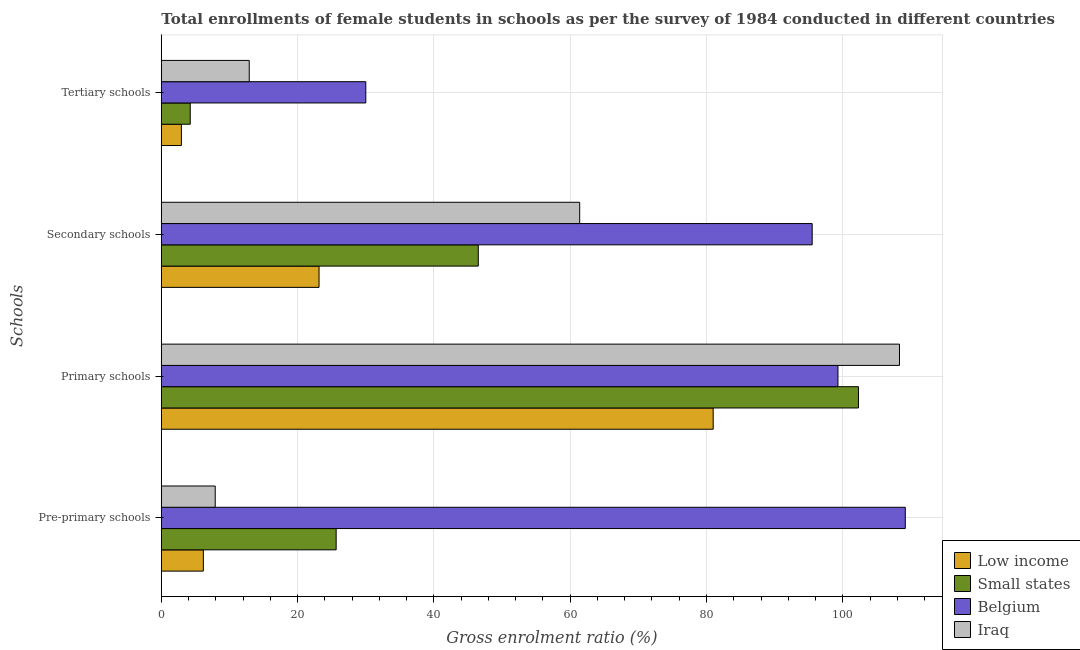How many different coloured bars are there?
Your answer should be compact. 4. Are the number of bars per tick equal to the number of legend labels?
Keep it short and to the point. Yes. Are the number of bars on each tick of the Y-axis equal?
Keep it short and to the point. Yes. How many bars are there on the 2nd tick from the top?
Provide a succinct answer. 4. How many bars are there on the 4th tick from the bottom?
Provide a short and direct response. 4. What is the label of the 3rd group of bars from the top?
Offer a terse response. Primary schools. What is the gross enrolment ratio(female) in secondary schools in Small states?
Offer a terse response. 46.51. Across all countries, what is the maximum gross enrolment ratio(female) in primary schools?
Make the answer very short. 108.32. Across all countries, what is the minimum gross enrolment ratio(female) in primary schools?
Make the answer very short. 80.98. In which country was the gross enrolment ratio(female) in tertiary schools maximum?
Your answer should be compact. Belgium. In which country was the gross enrolment ratio(female) in secondary schools minimum?
Provide a succinct answer. Low income. What is the total gross enrolment ratio(female) in pre-primary schools in the graph?
Your response must be concise. 148.91. What is the difference between the gross enrolment ratio(female) in pre-primary schools in Small states and that in Iraq?
Make the answer very short. 17.75. What is the difference between the gross enrolment ratio(female) in tertiary schools in Small states and the gross enrolment ratio(female) in pre-primary schools in Iraq?
Keep it short and to the point. -3.67. What is the average gross enrolment ratio(female) in tertiary schools per country?
Provide a short and direct response. 12.53. What is the difference between the gross enrolment ratio(female) in primary schools and gross enrolment ratio(female) in tertiary schools in Iraq?
Your response must be concise. 95.42. In how many countries, is the gross enrolment ratio(female) in primary schools greater than 4 %?
Your answer should be very brief. 4. What is the ratio of the gross enrolment ratio(female) in secondary schools in Small states to that in Low income?
Offer a terse response. 2.01. What is the difference between the highest and the second highest gross enrolment ratio(female) in secondary schools?
Offer a very short reply. 34.12. What is the difference between the highest and the lowest gross enrolment ratio(female) in pre-primary schools?
Keep it short and to the point. 103.01. In how many countries, is the gross enrolment ratio(female) in tertiary schools greater than the average gross enrolment ratio(female) in tertiary schools taken over all countries?
Keep it short and to the point. 2. What does the 4th bar from the top in Pre-primary schools represents?
Give a very brief answer. Low income. What does the 2nd bar from the bottom in Pre-primary schools represents?
Your answer should be compact. Small states. Is it the case that in every country, the sum of the gross enrolment ratio(female) in pre-primary schools and gross enrolment ratio(female) in primary schools is greater than the gross enrolment ratio(female) in secondary schools?
Your response must be concise. Yes. How many bars are there?
Provide a short and direct response. 16. Are all the bars in the graph horizontal?
Ensure brevity in your answer.  Yes. How many countries are there in the graph?
Ensure brevity in your answer.  4. What is the difference between two consecutive major ticks on the X-axis?
Provide a short and direct response. 20. Are the values on the major ticks of X-axis written in scientific E-notation?
Provide a succinct answer. No. Does the graph contain any zero values?
Provide a succinct answer. No. Where does the legend appear in the graph?
Offer a very short reply. Bottom right. What is the title of the graph?
Your answer should be compact. Total enrollments of female students in schools as per the survey of 1984 conducted in different countries. What is the label or title of the X-axis?
Ensure brevity in your answer.  Gross enrolment ratio (%). What is the label or title of the Y-axis?
Your answer should be compact. Schools. What is the Gross enrolment ratio (%) in Low income in Pre-primary schools?
Provide a succinct answer. 6.17. What is the Gross enrolment ratio (%) of Small states in Pre-primary schools?
Provide a succinct answer. 25.66. What is the Gross enrolment ratio (%) in Belgium in Pre-primary schools?
Give a very brief answer. 109.17. What is the Gross enrolment ratio (%) of Iraq in Pre-primary schools?
Keep it short and to the point. 7.91. What is the Gross enrolment ratio (%) of Low income in Primary schools?
Offer a terse response. 80.98. What is the Gross enrolment ratio (%) of Small states in Primary schools?
Ensure brevity in your answer.  102.3. What is the Gross enrolment ratio (%) in Belgium in Primary schools?
Keep it short and to the point. 99.29. What is the Gross enrolment ratio (%) in Iraq in Primary schools?
Offer a terse response. 108.32. What is the Gross enrolment ratio (%) in Low income in Secondary schools?
Your answer should be very brief. 23.15. What is the Gross enrolment ratio (%) in Small states in Secondary schools?
Keep it short and to the point. 46.51. What is the Gross enrolment ratio (%) of Belgium in Secondary schools?
Make the answer very short. 95.51. What is the Gross enrolment ratio (%) of Iraq in Secondary schools?
Offer a terse response. 61.39. What is the Gross enrolment ratio (%) of Low income in Tertiary schools?
Your answer should be very brief. 2.95. What is the Gross enrolment ratio (%) of Small states in Tertiary schools?
Offer a terse response. 4.24. What is the Gross enrolment ratio (%) of Belgium in Tertiary schools?
Ensure brevity in your answer.  30.01. What is the Gross enrolment ratio (%) in Iraq in Tertiary schools?
Offer a terse response. 12.9. Across all Schools, what is the maximum Gross enrolment ratio (%) in Low income?
Offer a terse response. 80.98. Across all Schools, what is the maximum Gross enrolment ratio (%) in Small states?
Offer a very short reply. 102.3. Across all Schools, what is the maximum Gross enrolment ratio (%) of Belgium?
Provide a succinct answer. 109.17. Across all Schools, what is the maximum Gross enrolment ratio (%) in Iraq?
Your answer should be very brief. 108.32. Across all Schools, what is the minimum Gross enrolment ratio (%) in Low income?
Your answer should be compact. 2.95. Across all Schools, what is the minimum Gross enrolment ratio (%) in Small states?
Your response must be concise. 4.24. Across all Schools, what is the minimum Gross enrolment ratio (%) of Belgium?
Provide a short and direct response. 30.01. Across all Schools, what is the minimum Gross enrolment ratio (%) of Iraq?
Provide a short and direct response. 7.91. What is the total Gross enrolment ratio (%) of Low income in the graph?
Your response must be concise. 113.24. What is the total Gross enrolment ratio (%) of Small states in the graph?
Make the answer very short. 178.71. What is the total Gross enrolment ratio (%) of Belgium in the graph?
Your response must be concise. 333.99. What is the total Gross enrolment ratio (%) in Iraq in the graph?
Offer a very short reply. 190.53. What is the difference between the Gross enrolment ratio (%) of Low income in Pre-primary schools and that in Primary schools?
Keep it short and to the point. -74.82. What is the difference between the Gross enrolment ratio (%) of Small states in Pre-primary schools and that in Primary schools?
Offer a very short reply. -76.64. What is the difference between the Gross enrolment ratio (%) of Belgium in Pre-primary schools and that in Primary schools?
Your response must be concise. 9.88. What is the difference between the Gross enrolment ratio (%) of Iraq in Pre-primary schools and that in Primary schools?
Make the answer very short. -100.41. What is the difference between the Gross enrolment ratio (%) of Low income in Pre-primary schools and that in Secondary schools?
Provide a short and direct response. -16.98. What is the difference between the Gross enrolment ratio (%) of Small states in Pre-primary schools and that in Secondary schools?
Make the answer very short. -20.86. What is the difference between the Gross enrolment ratio (%) of Belgium in Pre-primary schools and that in Secondary schools?
Your answer should be compact. 13.66. What is the difference between the Gross enrolment ratio (%) of Iraq in Pre-primary schools and that in Secondary schools?
Your response must be concise. -53.48. What is the difference between the Gross enrolment ratio (%) of Low income in Pre-primary schools and that in Tertiary schools?
Your answer should be very brief. 3.22. What is the difference between the Gross enrolment ratio (%) in Small states in Pre-primary schools and that in Tertiary schools?
Your answer should be very brief. 21.41. What is the difference between the Gross enrolment ratio (%) of Belgium in Pre-primary schools and that in Tertiary schools?
Provide a short and direct response. 79.17. What is the difference between the Gross enrolment ratio (%) in Iraq in Pre-primary schools and that in Tertiary schools?
Offer a terse response. -5. What is the difference between the Gross enrolment ratio (%) of Low income in Primary schools and that in Secondary schools?
Your answer should be very brief. 57.84. What is the difference between the Gross enrolment ratio (%) of Small states in Primary schools and that in Secondary schools?
Offer a very short reply. 55.79. What is the difference between the Gross enrolment ratio (%) in Belgium in Primary schools and that in Secondary schools?
Make the answer very short. 3.78. What is the difference between the Gross enrolment ratio (%) of Iraq in Primary schools and that in Secondary schools?
Your answer should be very brief. 46.93. What is the difference between the Gross enrolment ratio (%) of Low income in Primary schools and that in Tertiary schools?
Your response must be concise. 78.04. What is the difference between the Gross enrolment ratio (%) of Small states in Primary schools and that in Tertiary schools?
Provide a succinct answer. 98.06. What is the difference between the Gross enrolment ratio (%) of Belgium in Primary schools and that in Tertiary schools?
Make the answer very short. 69.29. What is the difference between the Gross enrolment ratio (%) of Iraq in Primary schools and that in Tertiary schools?
Provide a succinct answer. 95.42. What is the difference between the Gross enrolment ratio (%) of Low income in Secondary schools and that in Tertiary schools?
Ensure brevity in your answer.  20.2. What is the difference between the Gross enrolment ratio (%) in Small states in Secondary schools and that in Tertiary schools?
Your answer should be very brief. 42.27. What is the difference between the Gross enrolment ratio (%) of Belgium in Secondary schools and that in Tertiary schools?
Make the answer very short. 65.51. What is the difference between the Gross enrolment ratio (%) in Iraq in Secondary schools and that in Tertiary schools?
Your response must be concise. 48.49. What is the difference between the Gross enrolment ratio (%) of Low income in Pre-primary schools and the Gross enrolment ratio (%) of Small states in Primary schools?
Ensure brevity in your answer.  -96.13. What is the difference between the Gross enrolment ratio (%) in Low income in Pre-primary schools and the Gross enrolment ratio (%) in Belgium in Primary schools?
Keep it short and to the point. -93.12. What is the difference between the Gross enrolment ratio (%) in Low income in Pre-primary schools and the Gross enrolment ratio (%) in Iraq in Primary schools?
Your answer should be compact. -102.16. What is the difference between the Gross enrolment ratio (%) in Small states in Pre-primary schools and the Gross enrolment ratio (%) in Belgium in Primary schools?
Ensure brevity in your answer.  -73.64. What is the difference between the Gross enrolment ratio (%) in Small states in Pre-primary schools and the Gross enrolment ratio (%) in Iraq in Primary schools?
Provide a succinct answer. -82.67. What is the difference between the Gross enrolment ratio (%) of Belgium in Pre-primary schools and the Gross enrolment ratio (%) of Iraq in Primary schools?
Ensure brevity in your answer.  0.85. What is the difference between the Gross enrolment ratio (%) in Low income in Pre-primary schools and the Gross enrolment ratio (%) in Small states in Secondary schools?
Your answer should be very brief. -40.34. What is the difference between the Gross enrolment ratio (%) in Low income in Pre-primary schools and the Gross enrolment ratio (%) in Belgium in Secondary schools?
Offer a very short reply. -89.34. What is the difference between the Gross enrolment ratio (%) in Low income in Pre-primary schools and the Gross enrolment ratio (%) in Iraq in Secondary schools?
Your response must be concise. -55.23. What is the difference between the Gross enrolment ratio (%) in Small states in Pre-primary schools and the Gross enrolment ratio (%) in Belgium in Secondary schools?
Your answer should be compact. -69.86. What is the difference between the Gross enrolment ratio (%) in Small states in Pre-primary schools and the Gross enrolment ratio (%) in Iraq in Secondary schools?
Your answer should be very brief. -35.74. What is the difference between the Gross enrolment ratio (%) in Belgium in Pre-primary schools and the Gross enrolment ratio (%) in Iraq in Secondary schools?
Your response must be concise. 47.78. What is the difference between the Gross enrolment ratio (%) of Low income in Pre-primary schools and the Gross enrolment ratio (%) of Small states in Tertiary schools?
Give a very brief answer. 1.92. What is the difference between the Gross enrolment ratio (%) in Low income in Pre-primary schools and the Gross enrolment ratio (%) in Belgium in Tertiary schools?
Provide a succinct answer. -23.84. What is the difference between the Gross enrolment ratio (%) of Low income in Pre-primary schools and the Gross enrolment ratio (%) of Iraq in Tertiary schools?
Offer a very short reply. -6.74. What is the difference between the Gross enrolment ratio (%) of Small states in Pre-primary schools and the Gross enrolment ratio (%) of Belgium in Tertiary schools?
Your answer should be very brief. -4.35. What is the difference between the Gross enrolment ratio (%) in Small states in Pre-primary schools and the Gross enrolment ratio (%) in Iraq in Tertiary schools?
Provide a short and direct response. 12.75. What is the difference between the Gross enrolment ratio (%) of Belgium in Pre-primary schools and the Gross enrolment ratio (%) of Iraq in Tertiary schools?
Your answer should be compact. 96.27. What is the difference between the Gross enrolment ratio (%) of Low income in Primary schools and the Gross enrolment ratio (%) of Small states in Secondary schools?
Your answer should be very brief. 34.47. What is the difference between the Gross enrolment ratio (%) in Low income in Primary schools and the Gross enrolment ratio (%) in Belgium in Secondary schools?
Offer a terse response. -14.53. What is the difference between the Gross enrolment ratio (%) of Low income in Primary schools and the Gross enrolment ratio (%) of Iraq in Secondary schools?
Offer a very short reply. 19.59. What is the difference between the Gross enrolment ratio (%) in Small states in Primary schools and the Gross enrolment ratio (%) in Belgium in Secondary schools?
Give a very brief answer. 6.79. What is the difference between the Gross enrolment ratio (%) of Small states in Primary schools and the Gross enrolment ratio (%) of Iraq in Secondary schools?
Offer a very short reply. 40.91. What is the difference between the Gross enrolment ratio (%) of Belgium in Primary schools and the Gross enrolment ratio (%) of Iraq in Secondary schools?
Keep it short and to the point. 37.9. What is the difference between the Gross enrolment ratio (%) of Low income in Primary schools and the Gross enrolment ratio (%) of Small states in Tertiary schools?
Your answer should be very brief. 76.74. What is the difference between the Gross enrolment ratio (%) of Low income in Primary schools and the Gross enrolment ratio (%) of Belgium in Tertiary schools?
Your response must be concise. 50.98. What is the difference between the Gross enrolment ratio (%) of Low income in Primary schools and the Gross enrolment ratio (%) of Iraq in Tertiary schools?
Your response must be concise. 68.08. What is the difference between the Gross enrolment ratio (%) in Small states in Primary schools and the Gross enrolment ratio (%) in Belgium in Tertiary schools?
Your answer should be very brief. 72.29. What is the difference between the Gross enrolment ratio (%) in Small states in Primary schools and the Gross enrolment ratio (%) in Iraq in Tertiary schools?
Offer a terse response. 89.4. What is the difference between the Gross enrolment ratio (%) of Belgium in Primary schools and the Gross enrolment ratio (%) of Iraq in Tertiary schools?
Offer a terse response. 86.39. What is the difference between the Gross enrolment ratio (%) of Low income in Secondary schools and the Gross enrolment ratio (%) of Small states in Tertiary schools?
Provide a short and direct response. 18.9. What is the difference between the Gross enrolment ratio (%) in Low income in Secondary schools and the Gross enrolment ratio (%) in Belgium in Tertiary schools?
Keep it short and to the point. -6.86. What is the difference between the Gross enrolment ratio (%) of Low income in Secondary schools and the Gross enrolment ratio (%) of Iraq in Tertiary schools?
Make the answer very short. 10.24. What is the difference between the Gross enrolment ratio (%) in Small states in Secondary schools and the Gross enrolment ratio (%) in Belgium in Tertiary schools?
Your response must be concise. 16.51. What is the difference between the Gross enrolment ratio (%) of Small states in Secondary schools and the Gross enrolment ratio (%) of Iraq in Tertiary schools?
Provide a short and direct response. 33.61. What is the difference between the Gross enrolment ratio (%) in Belgium in Secondary schools and the Gross enrolment ratio (%) in Iraq in Tertiary schools?
Provide a succinct answer. 82.61. What is the average Gross enrolment ratio (%) of Low income per Schools?
Offer a terse response. 28.31. What is the average Gross enrolment ratio (%) of Small states per Schools?
Provide a short and direct response. 44.68. What is the average Gross enrolment ratio (%) in Belgium per Schools?
Give a very brief answer. 83.5. What is the average Gross enrolment ratio (%) in Iraq per Schools?
Offer a terse response. 47.63. What is the difference between the Gross enrolment ratio (%) in Low income and Gross enrolment ratio (%) in Small states in Pre-primary schools?
Your answer should be compact. -19.49. What is the difference between the Gross enrolment ratio (%) of Low income and Gross enrolment ratio (%) of Belgium in Pre-primary schools?
Provide a succinct answer. -103.01. What is the difference between the Gross enrolment ratio (%) in Low income and Gross enrolment ratio (%) in Iraq in Pre-primary schools?
Provide a succinct answer. -1.74. What is the difference between the Gross enrolment ratio (%) in Small states and Gross enrolment ratio (%) in Belgium in Pre-primary schools?
Provide a succinct answer. -83.52. What is the difference between the Gross enrolment ratio (%) of Small states and Gross enrolment ratio (%) of Iraq in Pre-primary schools?
Ensure brevity in your answer.  17.75. What is the difference between the Gross enrolment ratio (%) in Belgium and Gross enrolment ratio (%) in Iraq in Pre-primary schools?
Make the answer very short. 101.27. What is the difference between the Gross enrolment ratio (%) in Low income and Gross enrolment ratio (%) in Small states in Primary schools?
Provide a short and direct response. -21.32. What is the difference between the Gross enrolment ratio (%) of Low income and Gross enrolment ratio (%) of Belgium in Primary schools?
Your response must be concise. -18.31. What is the difference between the Gross enrolment ratio (%) in Low income and Gross enrolment ratio (%) in Iraq in Primary schools?
Your answer should be compact. -27.34. What is the difference between the Gross enrolment ratio (%) of Small states and Gross enrolment ratio (%) of Belgium in Primary schools?
Give a very brief answer. 3.01. What is the difference between the Gross enrolment ratio (%) of Small states and Gross enrolment ratio (%) of Iraq in Primary schools?
Offer a terse response. -6.02. What is the difference between the Gross enrolment ratio (%) in Belgium and Gross enrolment ratio (%) in Iraq in Primary schools?
Ensure brevity in your answer.  -9.03. What is the difference between the Gross enrolment ratio (%) of Low income and Gross enrolment ratio (%) of Small states in Secondary schools?
Your answer should be very brief. -23.37. What is the difference between the Gross enrolment ratio (%) in Low income and Gross enrolment ratio (%) in Belgium in Secondary schools?
Provide a short and direct response. -72.37. What is the difference between the Gross enrolment ratio (%) in Low income and Gross enrolment ratio (%) in Iraq in Secondary schools?
Ensure brevity in your answer.  -38.25. What is the difference between the Gross enrolment ratio (%) in Small states and Gross enrolment ratio (%) in Belgium in Secondary schools?
Make the answer very short. -49. What is the difference between the Gross enrolment ratio (%) in Small states and Gross enrolment ratio (%) in Iraq in Secondary schools?
Keep it short and to the point. -14.88. What is the difference between the Gross enrolment ratio (%) in Belgium and Gross enrolment ratio (%) in Iraq in Secondary schools?
Your response must be concise. 34.12. What is the difference between the Gross enrolment ratio (%) in Low income and Gross enrolment ratio (%) in Small states in Tertiary schools?
Give a very brief answer. -1.3. What is the difference between the Gross enrolment ratio (%) of Low income and Gross enrolment ratio (%) of Belgium in Tertiary schools?
Ensure brevity in your answer.  -27.06. What is the difference between the Gross enrolment ratio (%) in Low income and Gross enrolment ratio (%) in Iraq in Tertiary schools?
Keep it short and to the point. -9.96. What is the difference between the Gross enrolment ratio (%) of Small states and Gross enrolment ratio (%) of Belgium in Tertiary schools?
Your response must be concise. -25.76. What is the difference between the Gross enrolment ratio (%) in Small states and Gross enrolment ratio (%) in Iraq in Tertiary schools?
Your answer should be compact. -8.66. What is the difference between the Gross enrolment ratio (%) of Belgium and Gross enrolment ratio (%) of Iraq in Tertiary schools?
Give a very brief answer. 17.1. What is the ratio of the Gross enrolment ratio (%) in Low income in Pre-primary schools to that in Primary schools?
Make the answer very short. 0.08. What is the ratio of the Gross enrolment ratio (%) in Small states in Pre-primary schools to that in Primary schools?
Provide a succinct answer. 0.25. What is the ratio of the Gross enrolment ratio (%) of Belgium in Pre-primary schools to that in Primary schools?
Offer a terse response. 1.1. What is the ratio of the Gross enrolment ratio (%) of Iraq in Pre-primary schools to that in Primary schools?
Keep it short and to the point. 0.07. What is the ratio of the Gross enrolment ratio (%) of Low income in Pre-primary schools to that in Secondary schools?
Your response must be concise. 0.27. What is the ratio of the Gross enrolment ratio (%) of Small states in Pre-primary schools to that in Secondary schools?
Ensure brevity in your answer.  0.55. What is the ratio of the Gross enrolment ratio (%) in Belgium in Pre-primary schools to that in Secondary schools?
Your answer should be very brief. 1.14. What is the ratio of the Gross enrolment ratio (%) of Iraq in Pre-primary schools to that in Secondary schools?
Make the answer very short. 0.13. What is the ratio of the Gross enrolment ratio (%) in Low income in Pre-primary schools to that in Tertiary schools?
Give a very brief answer. 2.09. What is the ratio of the Gross enrolment ratio (%) in Small states in Pre-primary schools to that in Tertiary schools?
Provide a short and direct response. 6.05. What is the ratio of the Gross enrolment ratio (%) in Belgium in Pre-primary schools to that in Tertiary schools?
Provide a succinct answer. 3.64. What is the ratio of the Gross enrolment ratio (%) of Iraq in Pre-primary schools to that in Tertiary schools?
Your answer should be compact. 0.61. What is the ratio of the Gross enrolment ratio (%) of Low income in Primary schools to that in Secondary schools?
Offer a very short reply. 3.5. What is the ratio of the Gross enrolment ratio (%) of Small states in Primary schools to that in Secondary schools?
Your answer should be compact. 2.2. What is the ratio of the Gross enrolment ratio (%) in Belgium in Primary schools to that in Secondary schools?
Ensure brevity in your answer.  1.04. What is the ratio of the Gross enrolment ratio (%) in Iraq in Primary schools to that in Secondary schools?
Provide a short and direct response. 1.76. What is the ratio of the Gross enrolment ratio (%) in Low income in Primary schools to that in Tertiary schools?
Ensure brevity in your answer.  27.49. What is the ratio of the Gross enrolment ratio (%) of Small states in Primary schools to that in Tertiary schools?
Provide a succinct answer. 24.11. What is the ratio of the Gross enrolment ratio (%) in Belgium in Primary schools to that in Tertiary schools?
Keep it short and to the point. 3.31. What is the ratio of the Gross enrolment ratio (%) of Iraq in Primary schools to that in Tertiary schools?
Keep it short and to the point. 8.39. What is the ratio of the Gross enrolment ratio (%) of Low income in Secondary schools to that in Tertiary schools?
Your answer should be compact. 7.86. What is the ratio of the Gross enrolment ratio (%) of Small states in Secondary schools to that in Tertiary schools?
Ensure brevity in your answer.  10.96. What is the ratio of the Gross enrolment ratio (%) in Belgium in Secondary schools to that in Tertiary schools?
Your answer should be compact. 3.18. What is the ratio of the Gross enrolment ratio (%) in Iraq in Secondary schools to that in Tertiary schools?
Your answer should be compact. 4.76. What is the difference between the highest and the second highest Gross enrolment ratio (%) of Low income?
Give a very brief answer. 57.84. What is the difference between the highest and the second highest Gross enrolment ratio (%) in Small states?
Provide a succinct answer. 55.79. What is the difference between the highest and the second highest Gross enrolment ratio (%) in Belgium?
Your response must be concise. 9.88. What is the difference between the highest and the second highest Gross enrolment ratio (%) in Iraq?
Give a very brief answer. 46.93. What is the difference between the highest and the lowest Gross enrolment ratio (%) in Low income?
Offer a terse response. 78.04. What is the difference between the highest and the lowest Gross enrolment ratio (%) in Small states?
Provide a short and direct response. 98.06. What is the difference between the highest and the lowest Gross enrolment ratio (%) in Belgium?
Provide a succinct answer. 79.17. What is the difference between the highest and the lowest Gross enrolment ratio (%) of Iraq?
Offer a terse response. 100.41. 